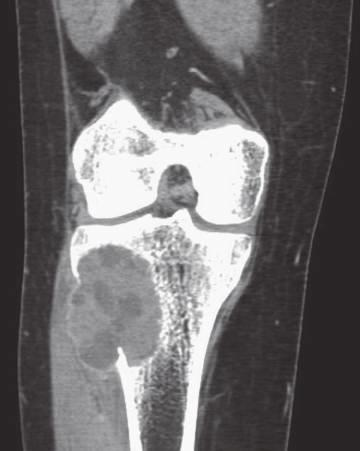what is coronal computed axial tomography scan showing?
Answer the question using a single word or phrase. Eccentric aneurysmal bone cyst of tibia 